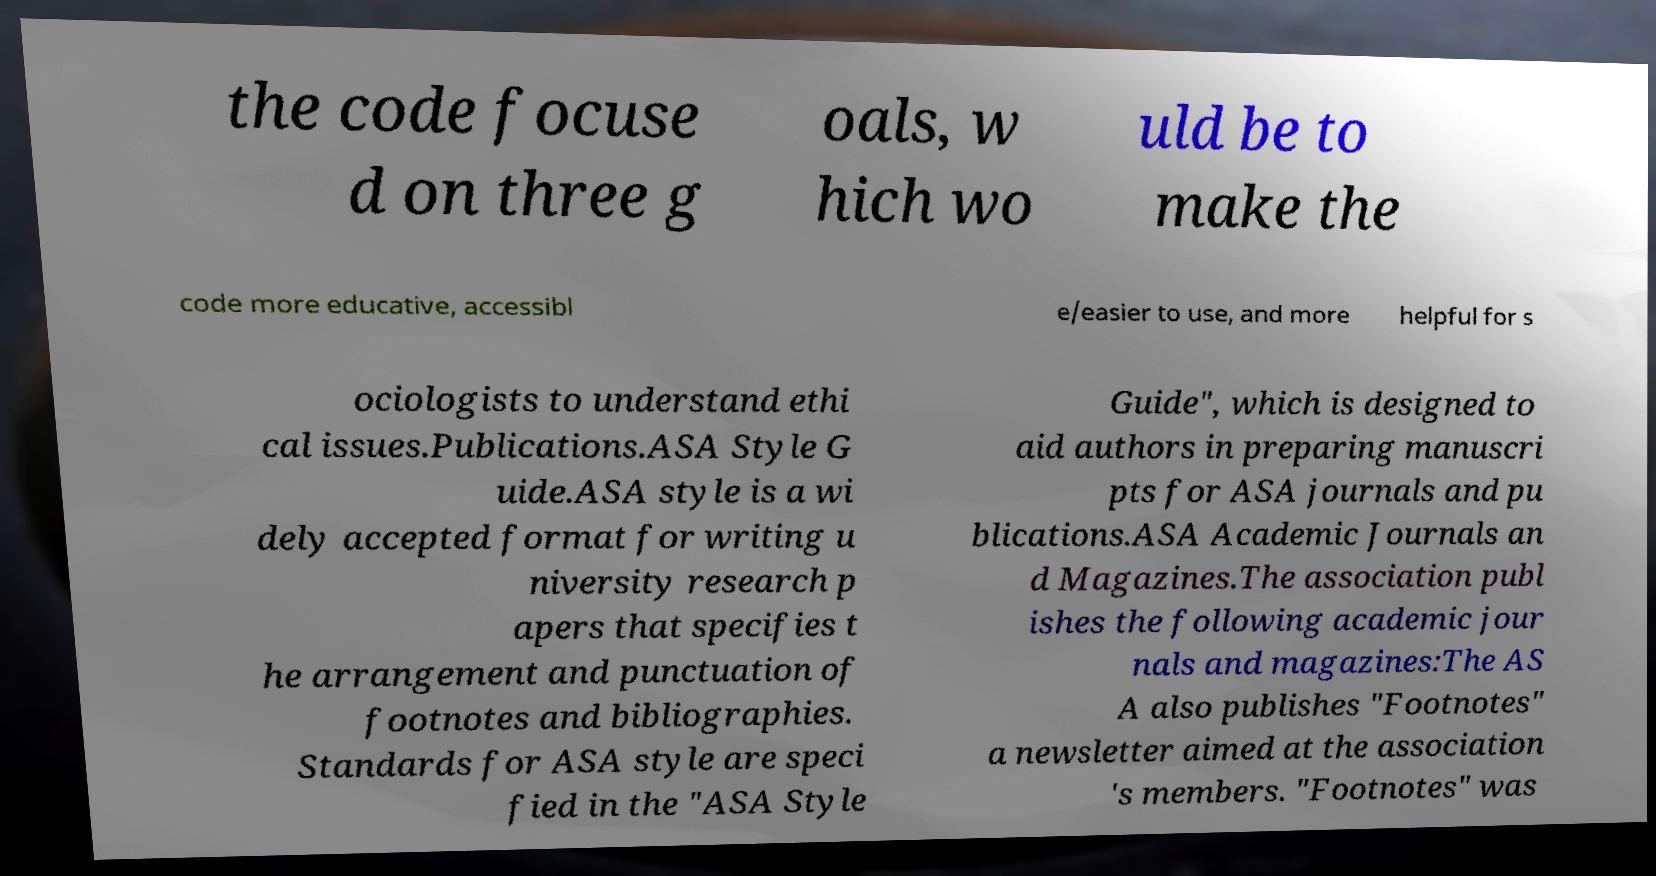What messages or text are displayed in this image? I need them in a readable, typed format. the code focuse d on three g oals, w hich wo uld be to make the code more educative, accessibl e/easier to use, and more helpful for s ociologists to understand ethi cal issues.Publications.ASA Style G uide.ASA style is a wi dely accepted format for writing u niversity research p apers that specifies t he arrangement and punctuation of footnotes and bibliographies. Standards for ASA style are speci fied in the "ASA Style Guide", which is designed to aid authors in preparing manuscri pts for ASA journals and pu blications.ASA Academic Journals an d Magazines.The association publ ishes the following academic jour nals and magazines:The AS A also publishes "Footnotes" a newsletter aimed at the association 's members. "Footnotes" was 